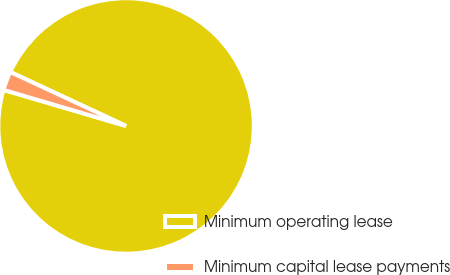Convert chart to OTSL. <chart><loc_0><loc_0><loc_500><loc_500><pie_chart><fcel>Minimum operating lease<fcel>Minimum capital lease payments<nl><fcel>97.62%<fcel>2.38%<nl></chart> 